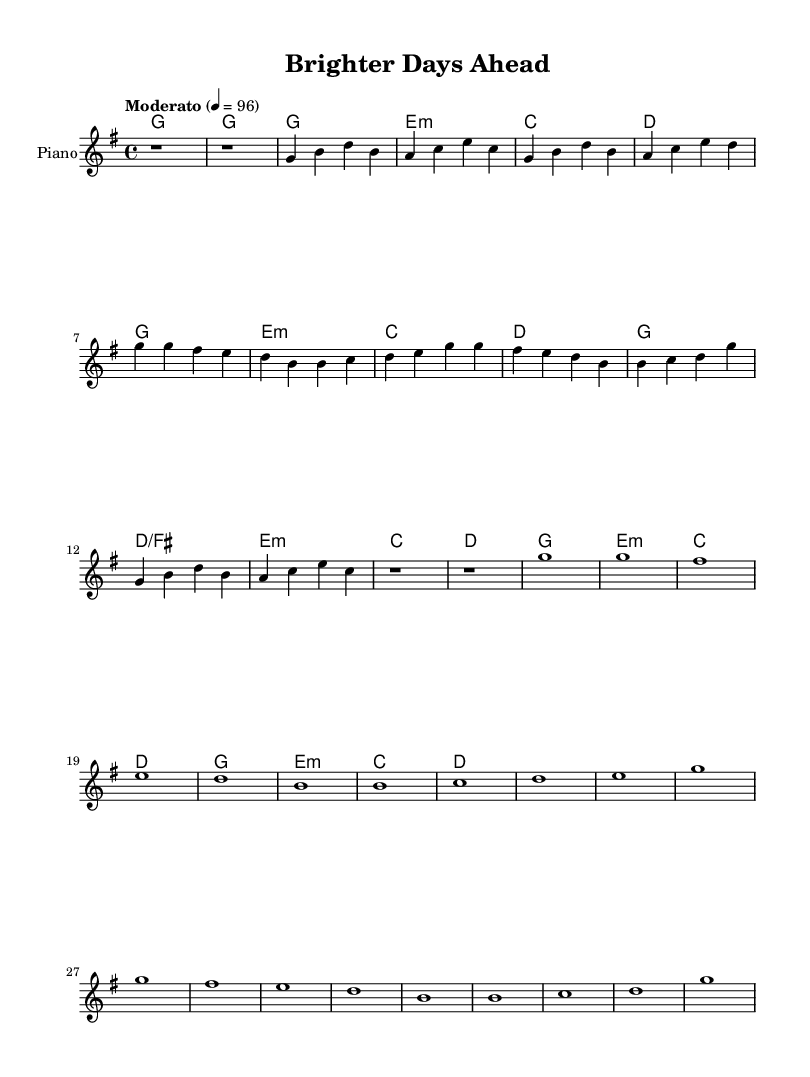What is the time signature of this music? The time signature is indicated by "4/4", which means there are four beats in each measure and the quarter note receives one beat.
Answer: 4/4 What is the key signature of this music? The key signature is G major, which has one sharp (F-sharp). This can be identified by the context of the notes in the music, which primarily consists of notes from the G major scale.
Answer: G major What tempo marking is indicated in this sheet music? The tempo marking is "Moderato" with a metronome marking of 96 beats per minute. This suggests a moderate speed, commonly found in pop music.
Answer: Moderato 96 How many measures does the final chorus consist of? The final chorus section has four measures, which can be counted by identifying the horizontal lines separating each measure and noting the notes.
Answer: 4 What is the chord progression for the chorus? The chord progression for the chorus follows a pattern of G, E minor, C, D, and G, and can be confirmed by looking at the chord symbols beneath the melody for the chorus section specifically.
Answer: G, E minor, C, D What is the instrument designated in the score? The instrument named in the score is "Piano," indicated at the beginning of the staff where the melody is written.
Answer: Piano Which section of the song features a piano solo? The bridge section, indicated by the pause (rest) in the melody line, suggests it is a piano solo hint, confirmed by the rest notation that shows no melody while the harmonies continue.
Answer: Bridge 